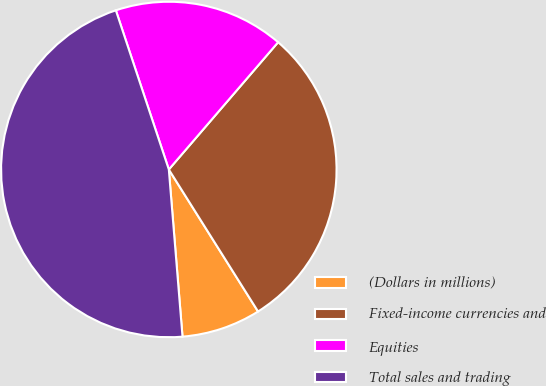<chart> <loc_0><loc_0><loc_500><loc_500><pie_chart><fcel>(Dollars in millions)<fcel>Fixed-income currencies and<fcel>Equities<fcel>Total sales and trading<nl><fcel>7.63%<fcel>29.78%<fcel>16.41%<fcel>46.19%<nl></chart> 